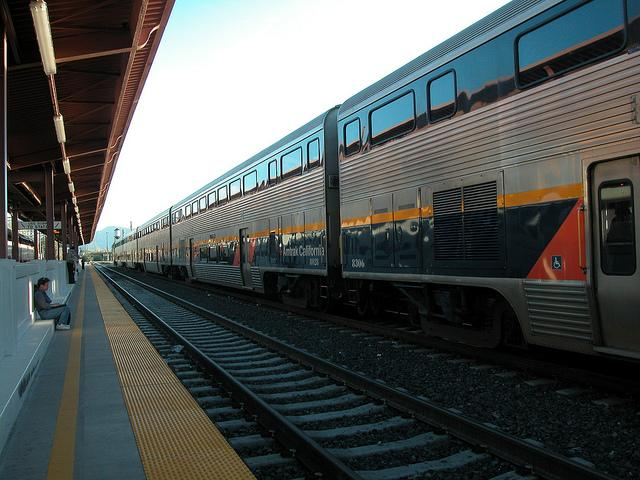What color is the triangle halves on the side of the bus next to the luggage holders?

Choices:
A) black
B) green
C) yellow
D) orange orange 